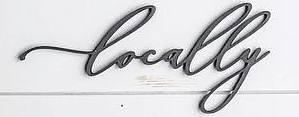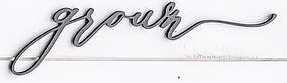Identify the words shown in these images in order, separated by a semicolon. Locally; grown 